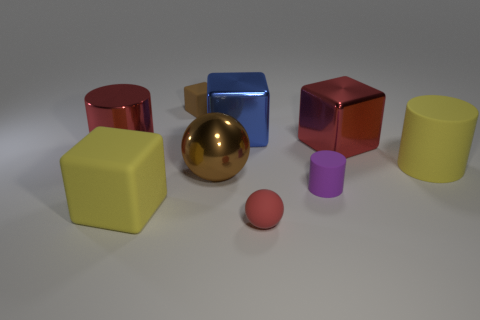What number of other metallic things have the same shape as the brown shiny thing?
Keep it short and to the point. 0. There is a cube that is the same color as the shiny sphere; what material is it?
Your answer should be compact. Rubber. How many objects are large blue cylinders or brown things that are in front of the red block?
Your answer should be very brief. 1. What is the large sphere made of?
Offer a very short reply. Metal. There is a yellow thing that is the same shape as the tiny brown matte thing; what is it made of?
Keep it short and to the point. Rubber. The large object behind the big red object that is to the right of the large red metallic cylinder is what color?
Keep it short and to the point. Blue. How many rubber things are big red blocks or large objects?
Make the answer very short. 2. Are the red block and the tiny cylinder made of the same material?
Your answer should be very brief. No. There is a blue thing behind the red metal thing right of the tiny purple rubber cylinder; what is it made of?
Keep it short and to the point. Metal. What number of small objects are either red rubber objects or yellow cubes?
Offer a terse response. 1. 